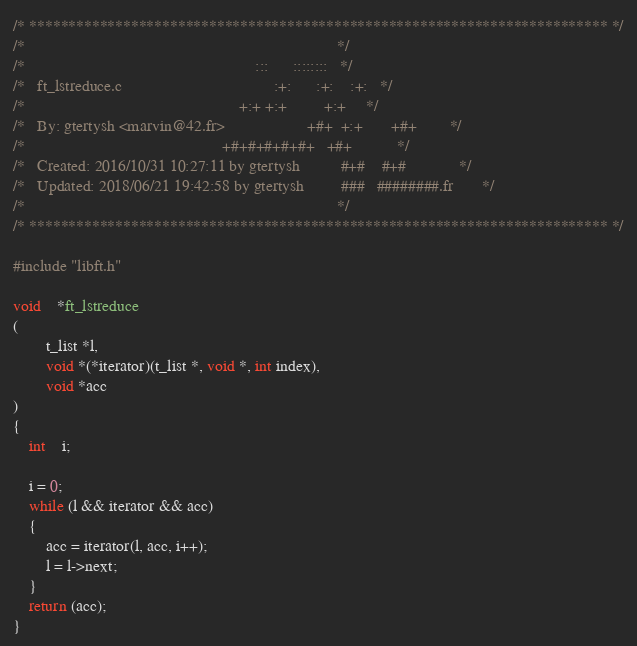Convert code to text. <code><loc_0><loc_0><loc_500><loc_500><_C_>/* ************************************************************************** */
/*                                                                            */
/*                                                        :::      ::::::::   */
/*   ft_lstreduce.c                                     :+:      :+:    :+:   */
/*                                                    +:+ +:+         +:+     */
/*   By: gtertysh <marvin@42.fr>                    +#+  +:+       +#+        */
/*                                                +#+#+#+#+#+   +#+           */
/*   Created: 2016/10/31 10:27:11 by gtertysh          #+#    #+#             */
/*   Updated: 2018/06/21 19:42:58 by gtertysh         ###   ########.fr       */
/*                                                                            */
/* ************************************************************************** */

#include "libft.h"

void	*ft_lstreduce
(
		t_list *l,
		void *(*iterator)(t_list *, void *, int index),
		void *acc
)
{
	int	i;

	i = 0;
	while (l && iterator && acc)
	{
		acc = iterator(l, acc, i++);
		l = l->next;
	}
	return (acc);
}
</code> 